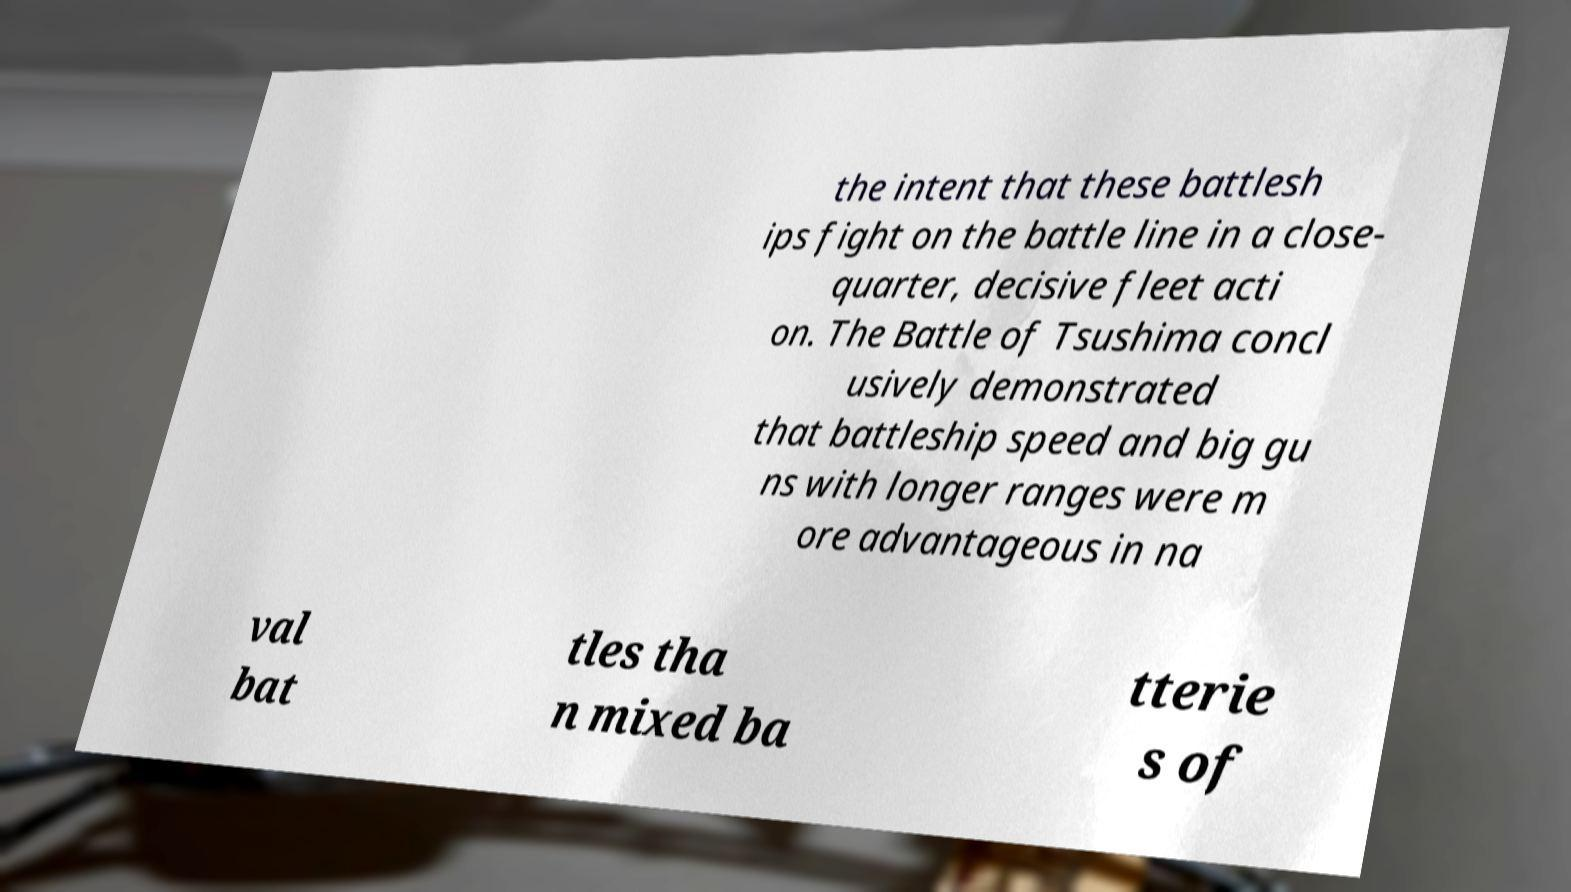What messages or text are displayed in this image? I need them in a readable, typed format. the intent that these battlesh ips fight on the battle line in a close- quarter, decisive fleet acti on. The Battle of Tsushima concl usively demonstrated that battleship speed and big gu ns with longer ranges were m ore advantageous in na val bat tles tha n mixed ba tterie s of 